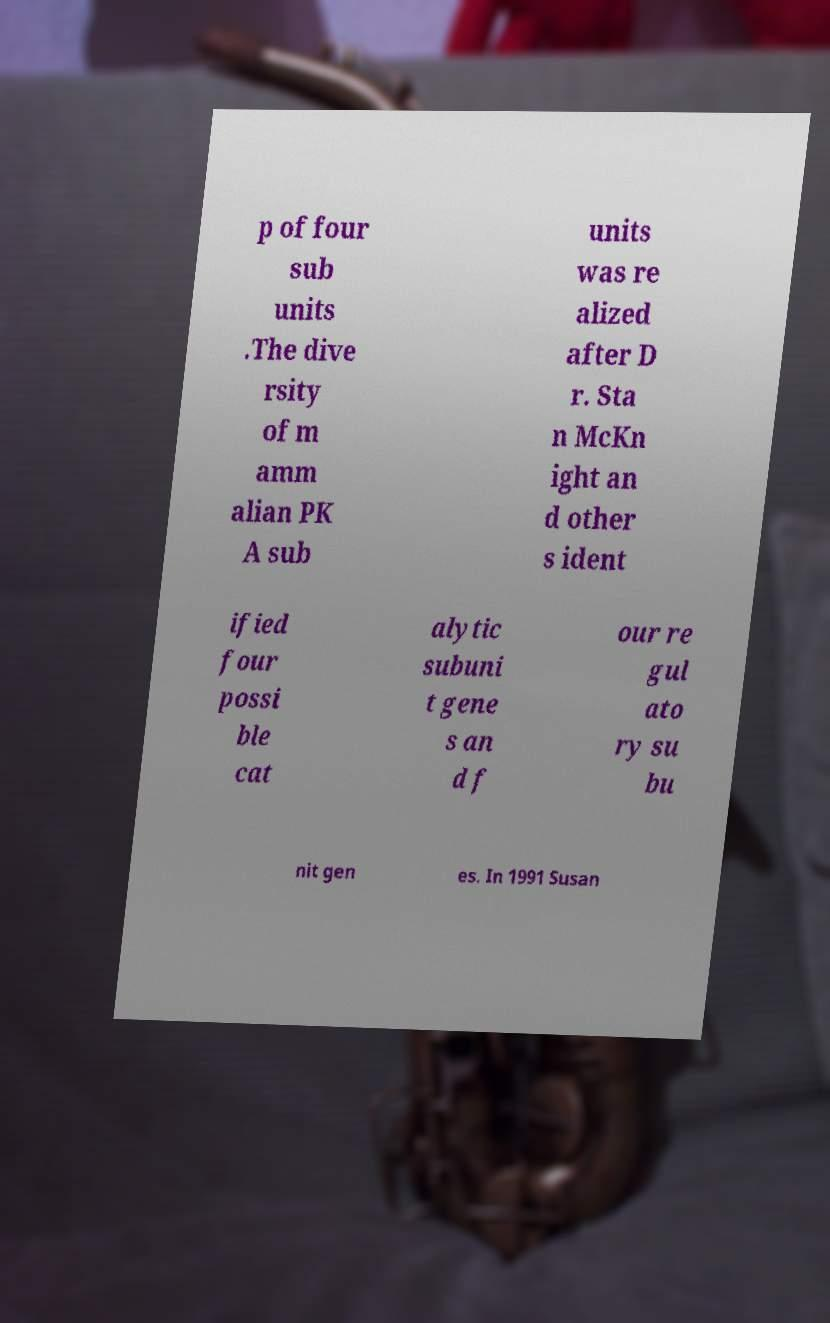Could you extract and type out the text from this image? p of four sub units .The dive rsity of m amm alian PK A sub units was re alized after D r. Sta n McKn ight an d other s ident ified four possi ble cat alytic subuni t gene s an d f our re gul ato ry su bu nit gen es. In 1991 Susan 